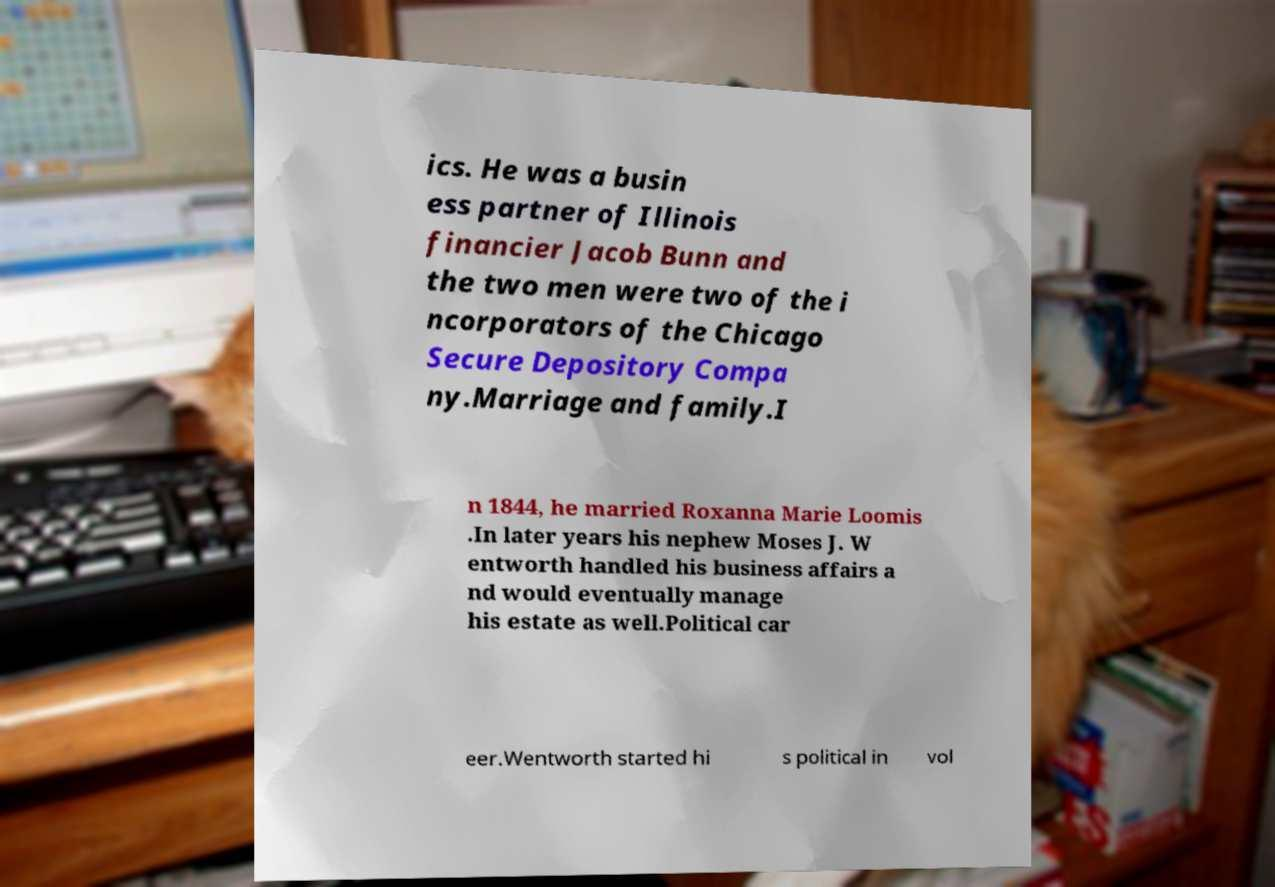Can you read and provide the text displayed in the image?This photo seems to have some interesting text. Can you extract and type it out for me? ics. He was a busin ess partner of Illinois financier Jacob Bunn and the two men were two of the i ncorporators of the Chicago Secure Depository Compa ny.Marriage and family.I n 1844, he married Roxanna Marie Loomis .In later years his nephew Moses J. W entworth handled his business affairs a nd would eventually manage his estate as well.Political car eer.Wentworth started hi s political in vol 